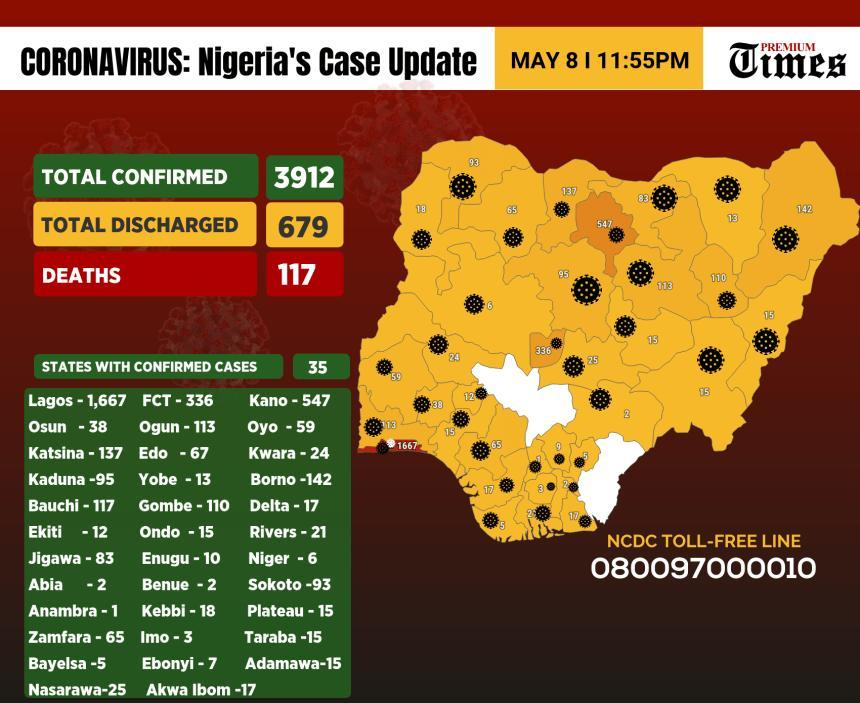How many confirmed COVID-19 cases are reported in the Borno state of Nigeria as of May 8?
Answer the question with a short phrase. 142 What is the number of confirmed Covid positive cases in Enugu state of Nigeria as of May 8? 10 Which state in Nigeria has reported the highest number of confirmed COVID-19 cases as of May 8? Lagos Which Nigerian state has reported the least number of confirmed COVID-19 cases as of May 8? Anambra Which state in Nigeria has reported the second highest number of confirmed COVID-19 cases as of May 8? Kano 